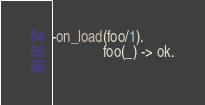<code> <loc_0><loc_0><loc_500><loc_500><_Erlang_>-on_load(foo/1).
              foo(_) -> ok.
             

</code> 